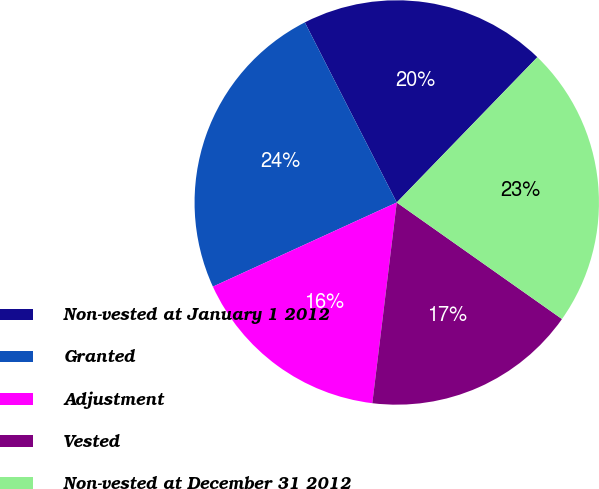Convert chart. <chart><loc_0><loc_0><loc_500><loc_500><pie_chart><fcel>Non-vested at January 1 2012<fcel>Granted<fcel>Adjustment<fcel>Vested<fcel>Non-vested at December 31 2012<nl><fcel>19.75%<fcel>24.32%<fcel>16.24%<fcel>17.15%<fcel>22.54%<nl></chart> 